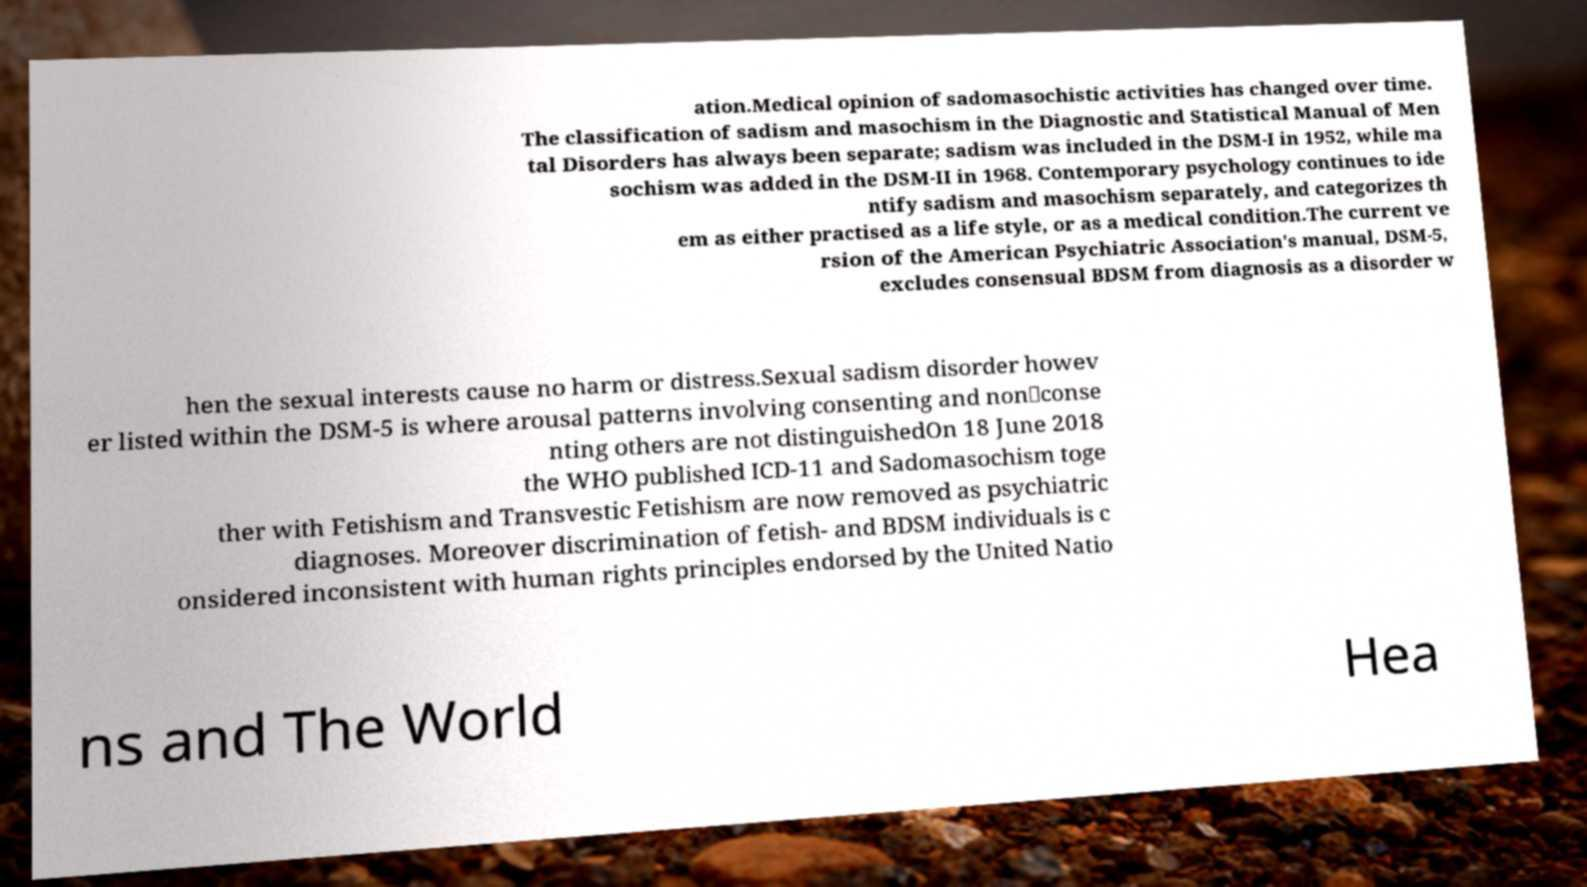Could you extract and type out the text from this image? ation.Medical opinion of sadomasochistic activities has changed over time. The classification of sadism and masochism in the Diagnostic and Statistical Manual of Men tal Disorders has always been separate; sadism was included in the DSM-I in 1952, while ma sochism was added in the DSM-II in 1968. Contemporary psychology continues to ide ntify sadism and masochism separately, and categorizes th em as either practised as a life style, or as a medical condition.The current ve rsion of the American Psychiatric Association's manual, DSM-5, excludes consensual BDSM from diagnosis as a disorder w hen the sexual interests cause no harm or distress.Sexual sadism disorder howev er listed within the DSM-5 is where arousal patterns involving consenting and non‐conse nting others are not distinguishedOn 18 June 2018 the WHO published ICD-11 and Sadomasochism toge ther with Fetishism and Transvestic Fetishism are now removed as psychiatric diagnoses. Moreover discrimination of fetish- and BDSM individuals is c onsidered inconsistent with human rights principles endorsed by the United Natio ns and The World Hea 